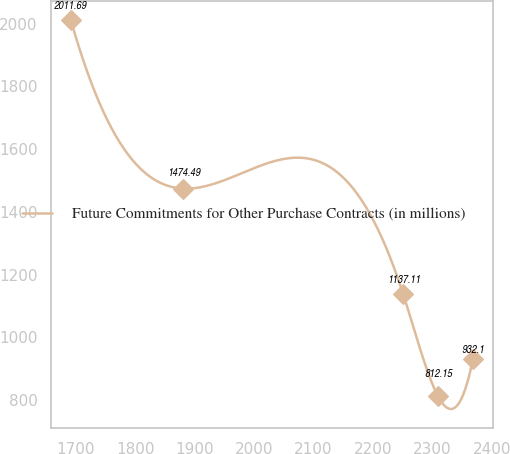Convert chart. <chart><loc_0><loc_0><loc_500><loc_500><line_chart><ecel><fcel>Future Commitments for Other Purchase Contracts (in millions)<nl><fcel>1691.67<fcel>2011.69<nl><fcel>1881.19<fcel>1474.49<nl><fcel>2250.88<fcel>1137.11<nl><fcel>2309.51<fcel>812.15<nl><fcel>2368.14<fcel>932.1<nl></chart> 